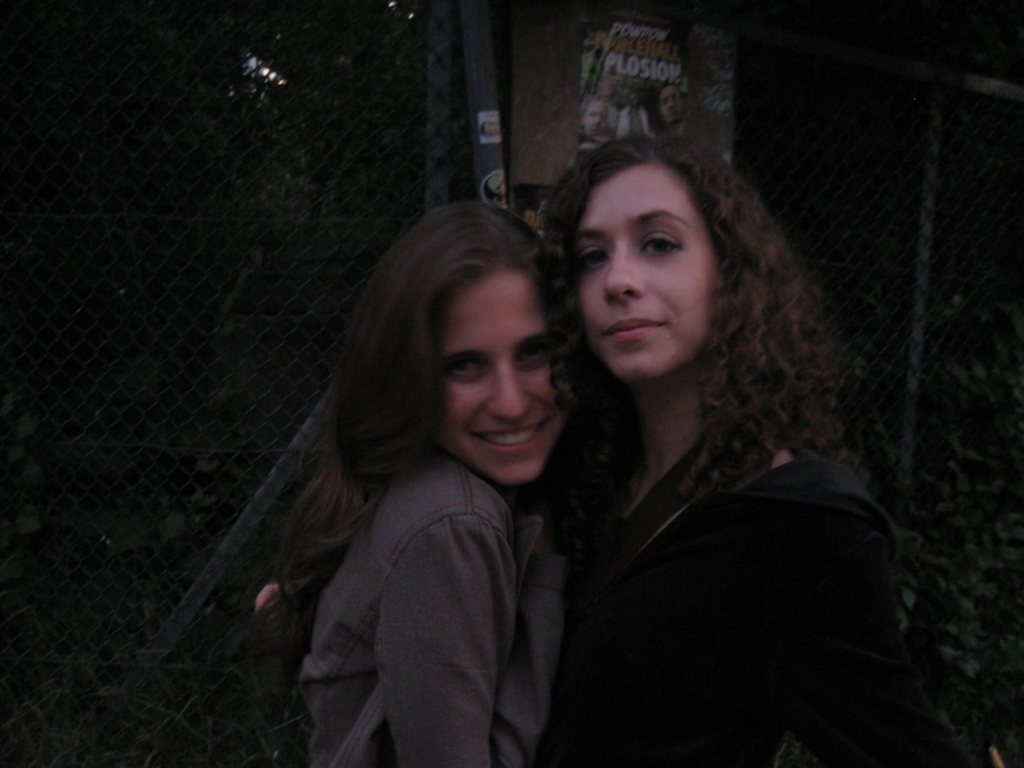What is the overall brightness of the image?
A. High
B. Bright
C. Low
Answer with the option's letter from the given choices directly.
 C. 